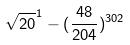<formula> <loc_0><loc_0><loc_500><loc_500>\sqrt { 2 0 } ^ { 1 } - ( \frac { 4 8 } { 2 0 4 } ) ^ { 3 0 2 }</formula> 